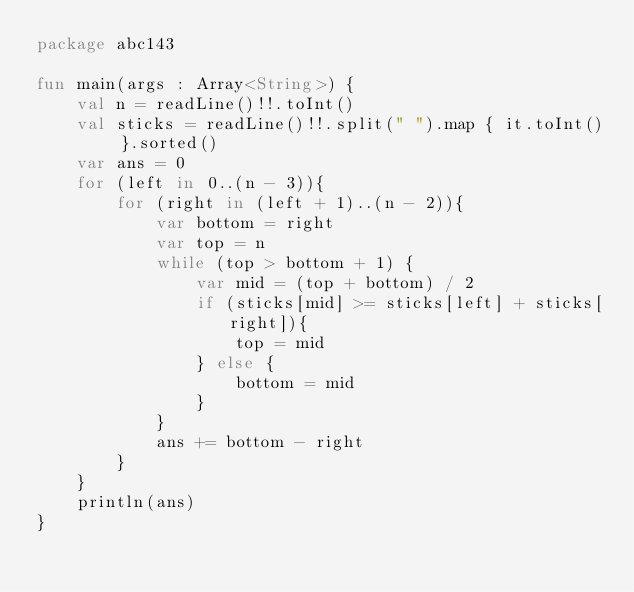Convert code to text. <code><loc_0><loc_0><loc_500><loc_500><_Kotlin_>package abc143

fun main(args : Array<String>) {
    val n = readLine()!!.toInt()
    val sticks = readLine()!!.split(" ").map { it.toInt() }.sorted()
    var ans = 0
    for (left in 0..(n - 3)){
        for (right in (left + 1)..(n - 2)){
            var bottom = right
            var top = n
            while (top > bottom + 1) {
                var mid = (top + bottom) / 2
                if (sticks[mid] >= sticks[left] + sticks[right]){
                    top = mid
                } else {
                    bottom = mid
                }
            }
            ans += bottom - right
        }
    }
    println(ans)
}
</code> 